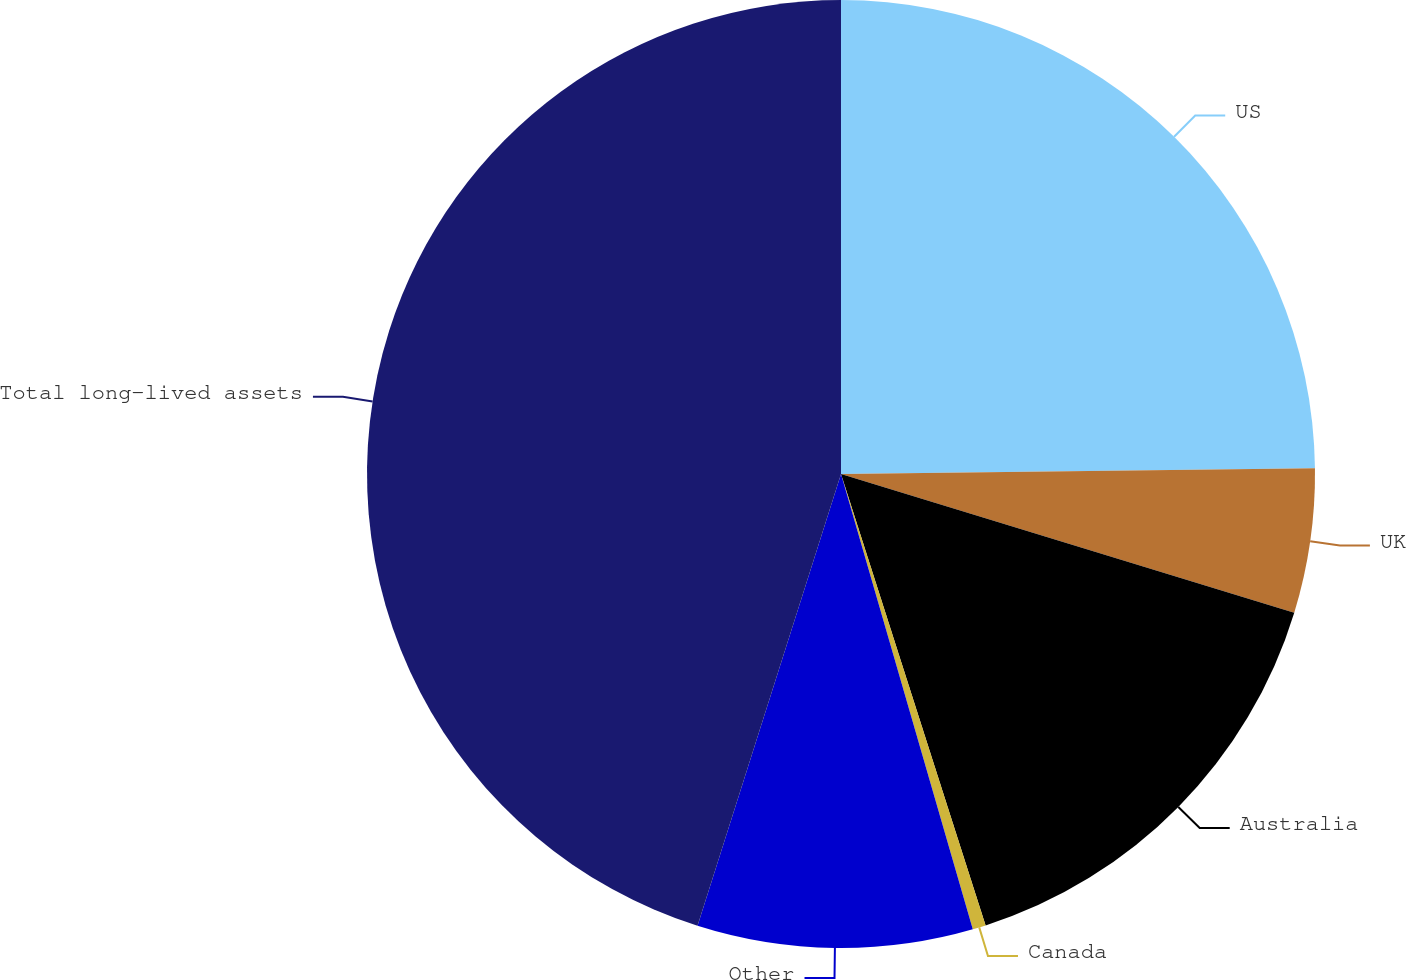Convert chart to OTSL. <chart><loc_0><loc_0><loc_500><loc_500><pie_chart><fcel>US<fcel>UK<fcel>Australia<fcel>Canada<fcel>Other<fcel>Total long-lived assets<nl><fcel>24.81%<fcel>4.92%<fcel>15.34%<fcel>0.45%<fcel>9.38%<fcel>45.11%<nl></chart> 